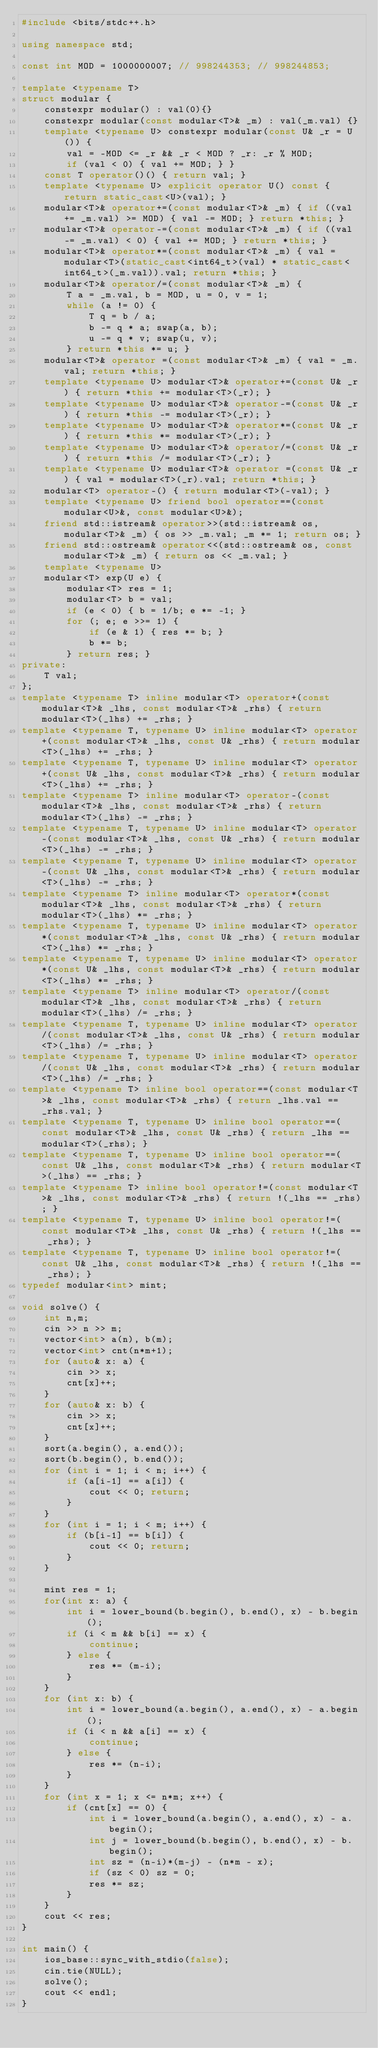<code> <loc_0><loc_0><loc_500><loc_500><_C++_>#include <bits/stdc++.h>

using namespace std;

const int MOD = 1000000007; // 998244353; // 998244853;

template <typename T>
struct modular {
    constexpr modular() : val(0){}
    constexpr modular(const modular<T>& _m) : val(_m.val) {}
    template <typename U> constexpr modular(const U& _r = U()) {
        val = -MOD <= _r && _r < MOD ? _r: _r % MOD;
        if (val < 0) { val += MOD; } }
    const T operator()() { return val; }
    template <typename U> explicit operator U() const { return static_cast<U>(val); }
    modular<T>& operator+=(const modular<T>& _m) { if ((val += _m.val) >= MOD) { val -= MOD; } return *this; }
    modular<T>& operator-=(const modular<T>& _m) { if ((val -= _m.val) < 0) { val += MOD; } return *this; }
    modular<T>& operator*=(const modular<T>& _m) { val = modular<T>(static_cast<int64_t>(val) * static_cast<int64_t>(_m.val)).val; return *this; }
    modular<T>& operator/=(const modular<T>& _m) {
        T a = _m.val, b = MOD, u = 0, v = 1;
        while (a != 0) {
            T q = b / a;
            b -= q * a; swap(a, b);
            u -= q * v; swap(u, v); 
        } return *this *= u; }
    modular<T>& operator =(const modular<T>& _m) { val = _m.val; return *this; }
    template <typename U> modular<T>& operator+=(const U& _r) { return *this += modular<T>(_r); }
    template <typename U> modular<T>& operator-=(const U& _r) { return *this -= modular<T>(_r); }
    template <typename U> modular<T>& operator*=(const U& _r) { return *this *= modular<T>(_r); }
    template <typename U> modular<T>& operator/=(const U& _r) { return *this /= modular<T>(_r); } 
    template <typename U> modular<T>& operator =(const U& _r) { val = modular<T>(_r).val; return *this; }
    modular<T> operator-() { return modular<T>(-val); }    
    template <typename U> friend bool operator==(const modular<U>&, const modular<U>&);
    friend std::istream& operator>>(std::istream& os, modular<T>& _m) { os >> _m.val; _m *= 1; return os; }
    friend std::ostream& operator<<(std::ostream& os, const modular<T>& _m) { return os << _m.val; }
    template <typename U>
    modular<T> exp(U e) {
        modular<T> res = 1;
        modular<T> b = val;
        if (e < 0) { b = 1/b; e *= -1; }
        for (; e; e >>= 1) {
            if (e & 1) { res *= b; }
            b *= b;
        } return res; }
private:
    T val;
};
template <typename T> inline modular<T> operator+(const modular<T>& _lhs, const modular<T>& _rhs) { return modular<T>(_lhs) += _rhs; }
template <typename T, typename U> inline modular<T> operator+(const modular<T>& _lhs, const U& _rhs) { return modular<T>(_lhs) += _rhs; }
template <typename T, typename U> inline modular<T> operator+(const U& _lhs, const modular<T>& _rhs) { return modular<T>(_lhs) += _rhs; }
template <typename T> inline modular<T> operator-(const modular<T>& _lhs, const modular<T>& _rhs) { return modular<T>(_lhs) -= _rhs; }
template <typename T, typename U> inline modular<T> operator-(const modular<T>& _lhs, const U& _rhs) { return modular<T>(_lhs) -= _rhs; }
template <typename T, typename U> inline modular<T> operator-(const U& _lhs, const modular<T>& _rhs) { return modular<T>(_lhs) -= _rhs; }
template <typename T> inline modular<T> operator*(const modular<T>& _lhs, const modular<T>& _rhs) { return modular<T>(_lhs) *= _rhs; }
template <typename T, typename U> inline modular<T> operator*(const modular<T>& _lhs, const U& _rhs) { return modular<T>(_lhs) *= _rhs; }
template <typename T, typename U> inline modular<T> operator*(const U& _lhs, const modular<T>& _rhs) { return modular<T>(_lhs) *= _rhs; }
template <typename T> inline modular<T> operator/(const modular<T>& _lhs, const modular<T>& _rhs) { return modular<T>(_lhs) /= _rhs; }
template <typename T, typename U> inline modular<T> operator/(const modular<T>& _lhs, const U& _rhs) { return modular<T>(_lhs) /= _rhs; }
template <typename T, typename U> inline modular<T> operator/(const U& _lhs, const modular<T>& _rhs) { return modular<T>(_lhs) /= _rhs; }
template <typename T> inline bool operator==(const modular<T>& _lhs, const modular<T>& _rhs) { return _lhs.val == _rhs.val; }
template <typename T, typename U> inline bool operator==(const modular<T>& _lhs, const U& _rhs) { return _lhs == modular<T>(_rhs); }
template <typename T, typename U> inline bool operator==(const U& _lhs, const modular<T>& _rhs) { return modular<T>(_lhs) == _rhs; }
template <typename T> inline bool operator!=(const modular<T>& _lhs, const modular<T>& _rhs) { return !(_lhs == _rhs); }
template <typename T, typename U> inline bool operator!=(const modular<T>& _lhs, const U& _rhs) { return !(_lhs == _rhs); }
template <typename T, typename U> inline bool operator!=(const U& _lhs, const modular<T>& _rhs) { return !(_lhs == _rhs); }
typedef modular<int> mint;

void solve() {
    int n,m;
    cin >> n >> m;
    vector<int> a(n), b(m);
    vector<int> cnt(n*m+1);
    for (auto& x: a) {
        cin >> x;
        cnt[x]++;
    }
    for (auto& x: b) {
        cin >> x;
        cnt[x]++;
    }
    sort(a.begin(), a.end());
    sort(b.begin(), b.end());
    for (int i = 1; i < n; i++) {
        if (a[i-1] == a[i]) {
            cout << 0; return;
        }
    }
    for (int i = 1; i < m; i++) {
        if (b[i-1] == b[i]) {
            cout << 0; return;
        }
    }
    
    mint res = 1;
    for(int x: a) {
        int i = lower_bound(b.begin(), b.end(), x) - b.begin();
        if (i < m && b[i] == x) {
            continue;
        } else {
            res *= (m-i);
        }
    }
    for (int x: b) {
        int i = lower_bound(a.begin(), a.end(), x) - a.begin();
        if (i < n && a[i] == x) {
            continue;
        } else {
            res *= (n-i);
        }
    }
    for (int x = 1; x <= n*m; x++) {
        if (cnt[x] == 0) {
            int i = lower_bound(a.begin(), a.end(), x) - a.begin();
            int j = lower_bound(b.begin(), b.end(), x) - b.begin();
            int sz = (n-i)*(m-j) - (n*m - x);
            if (sz < 0) sz = 0;
            res *= sz;
        }
    }
    cout << res;
}

int main() {
    ios_base::sync_with_stdio(false);
    cin.tie(NULL);
    solve();
    cout << endl;
}
</code> 